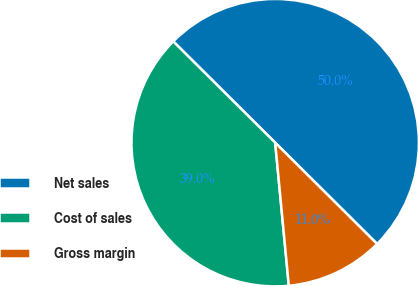<chart> <loc_0><loc_0><loc_500><loc_500><pie_chart><fcel>Net sales<fcel>Cost of sales<fcel>Gross margin<nl><fcel>50.0%<fcel>38.96%<fcel>11.04%<nl></chart> 